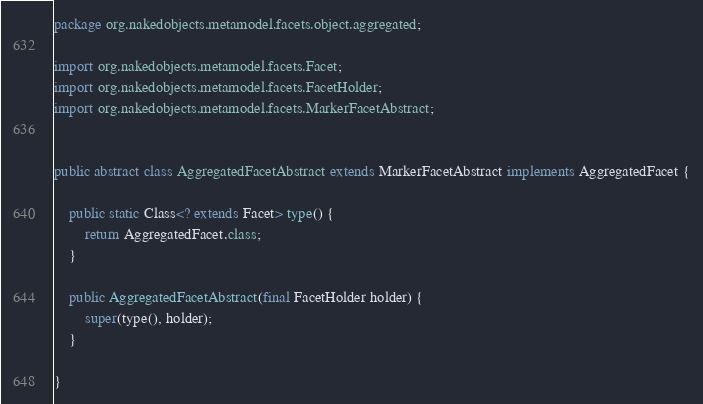<code> <loc_0><loc_0><loc_500><loc_500><_Java_>package org.nakedobjects.metamodel.facets.object.aggregated;

import org.nakedobjects.metamodel.facets.Facet;
import org.nakedobjects.metamodel.facets.FacetHolder;
import org.nakedobjects.metamodel.facets.MarkerFacetAbstract;


public abstract class AggregatedFacetAbstract extends MarkerFacetAbstract implements AggregatedFacet {

    public static Class<? extends Facet> type() {
        return AggregatedFacet.class;
    }

    public AggregatedFacetAbstract(final FacetHolder holder) {
        super(type(), holder);
    }

}
</code> 